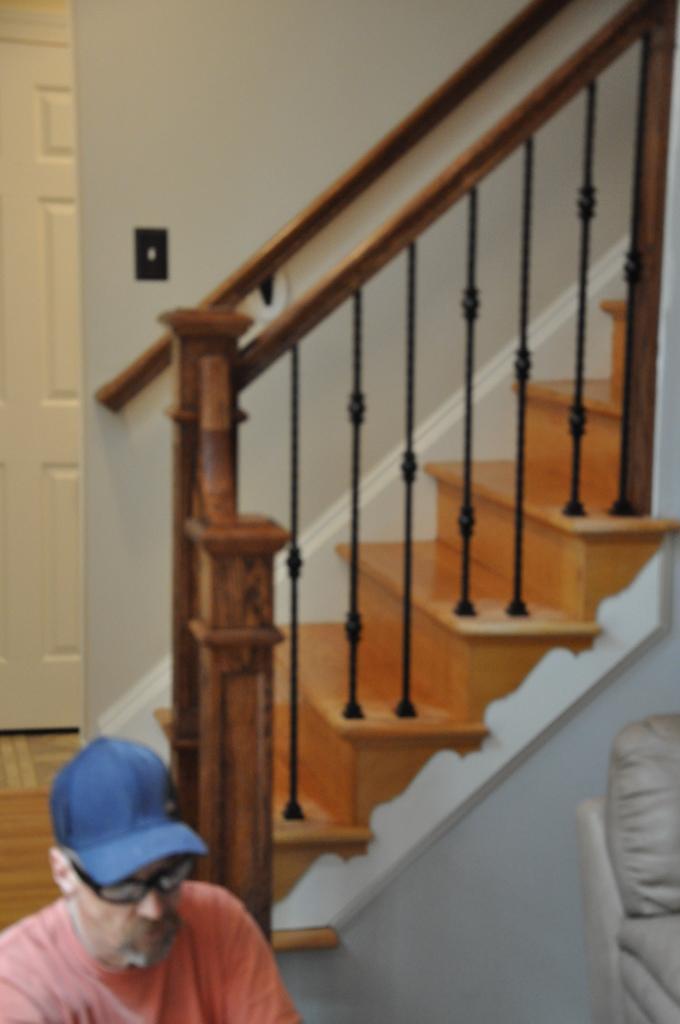How would you summarize this image in a sentence or two? In this image we can see a person sitting, and he is wearing a cap, beside him there is a crouch, we can also see a staircase, there is a door and a switch. 